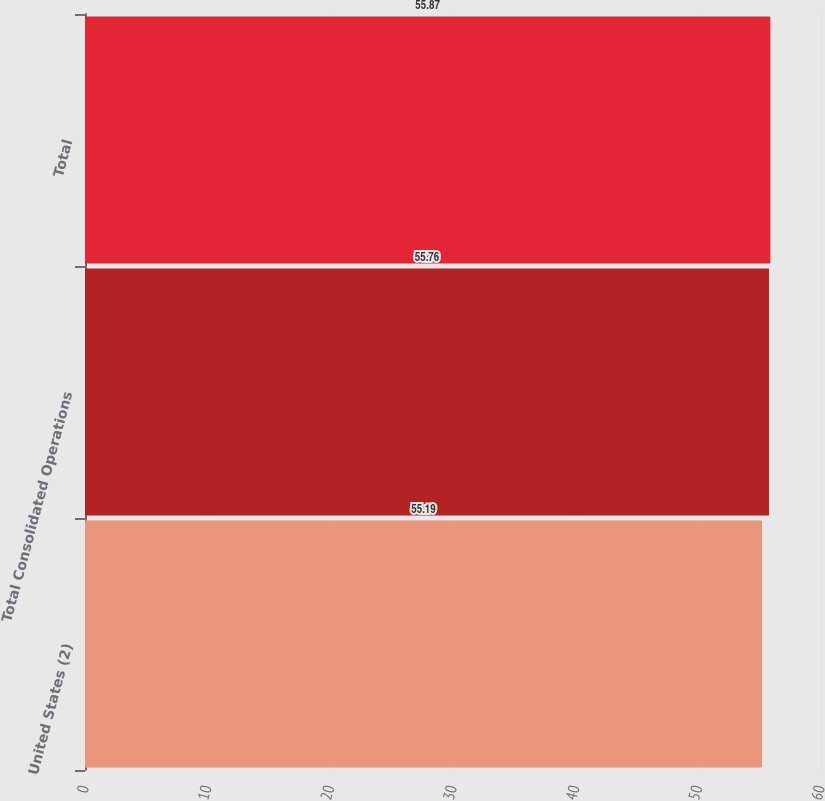Convert chart to OTSL. <chart><loc_0><loc_0><loc_500><loc_500><bar_chart><fcel>United States (2)<fcel>Total Consolidated Operations<fcel>Total<nl><fcel>55.19<fcel>55.76<fcel>55.87<nl></chart> 